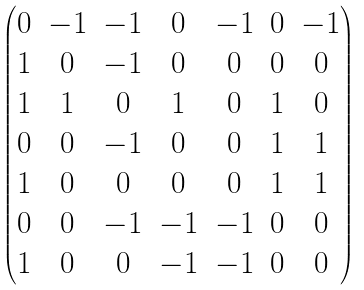<formula> <loc_0><loc_0><loc_500><loc_500>\begin{pmatrix} 0 & - 1 & - 1 & 0 & - 1 & 0 & - 1 \\ 1 & 0 & - 1 & 0 & 0 & 0 & 0 \\ 1 & 1 & 0 & 1 & 0 & 1 & 0 \\ 0 & 0 & - 1 & 0 & 0 & 1 & 1 \\ 1 & 0 & 0 & 0 & 0 & 1 & 1 \\ 0 & 0 & - 1 & - 1 & - 1 & 0 & 0 \\ 1 & 0 & 0 & - 1 & - 1 & 0 & 0 \end{pmatrix}</formula> 